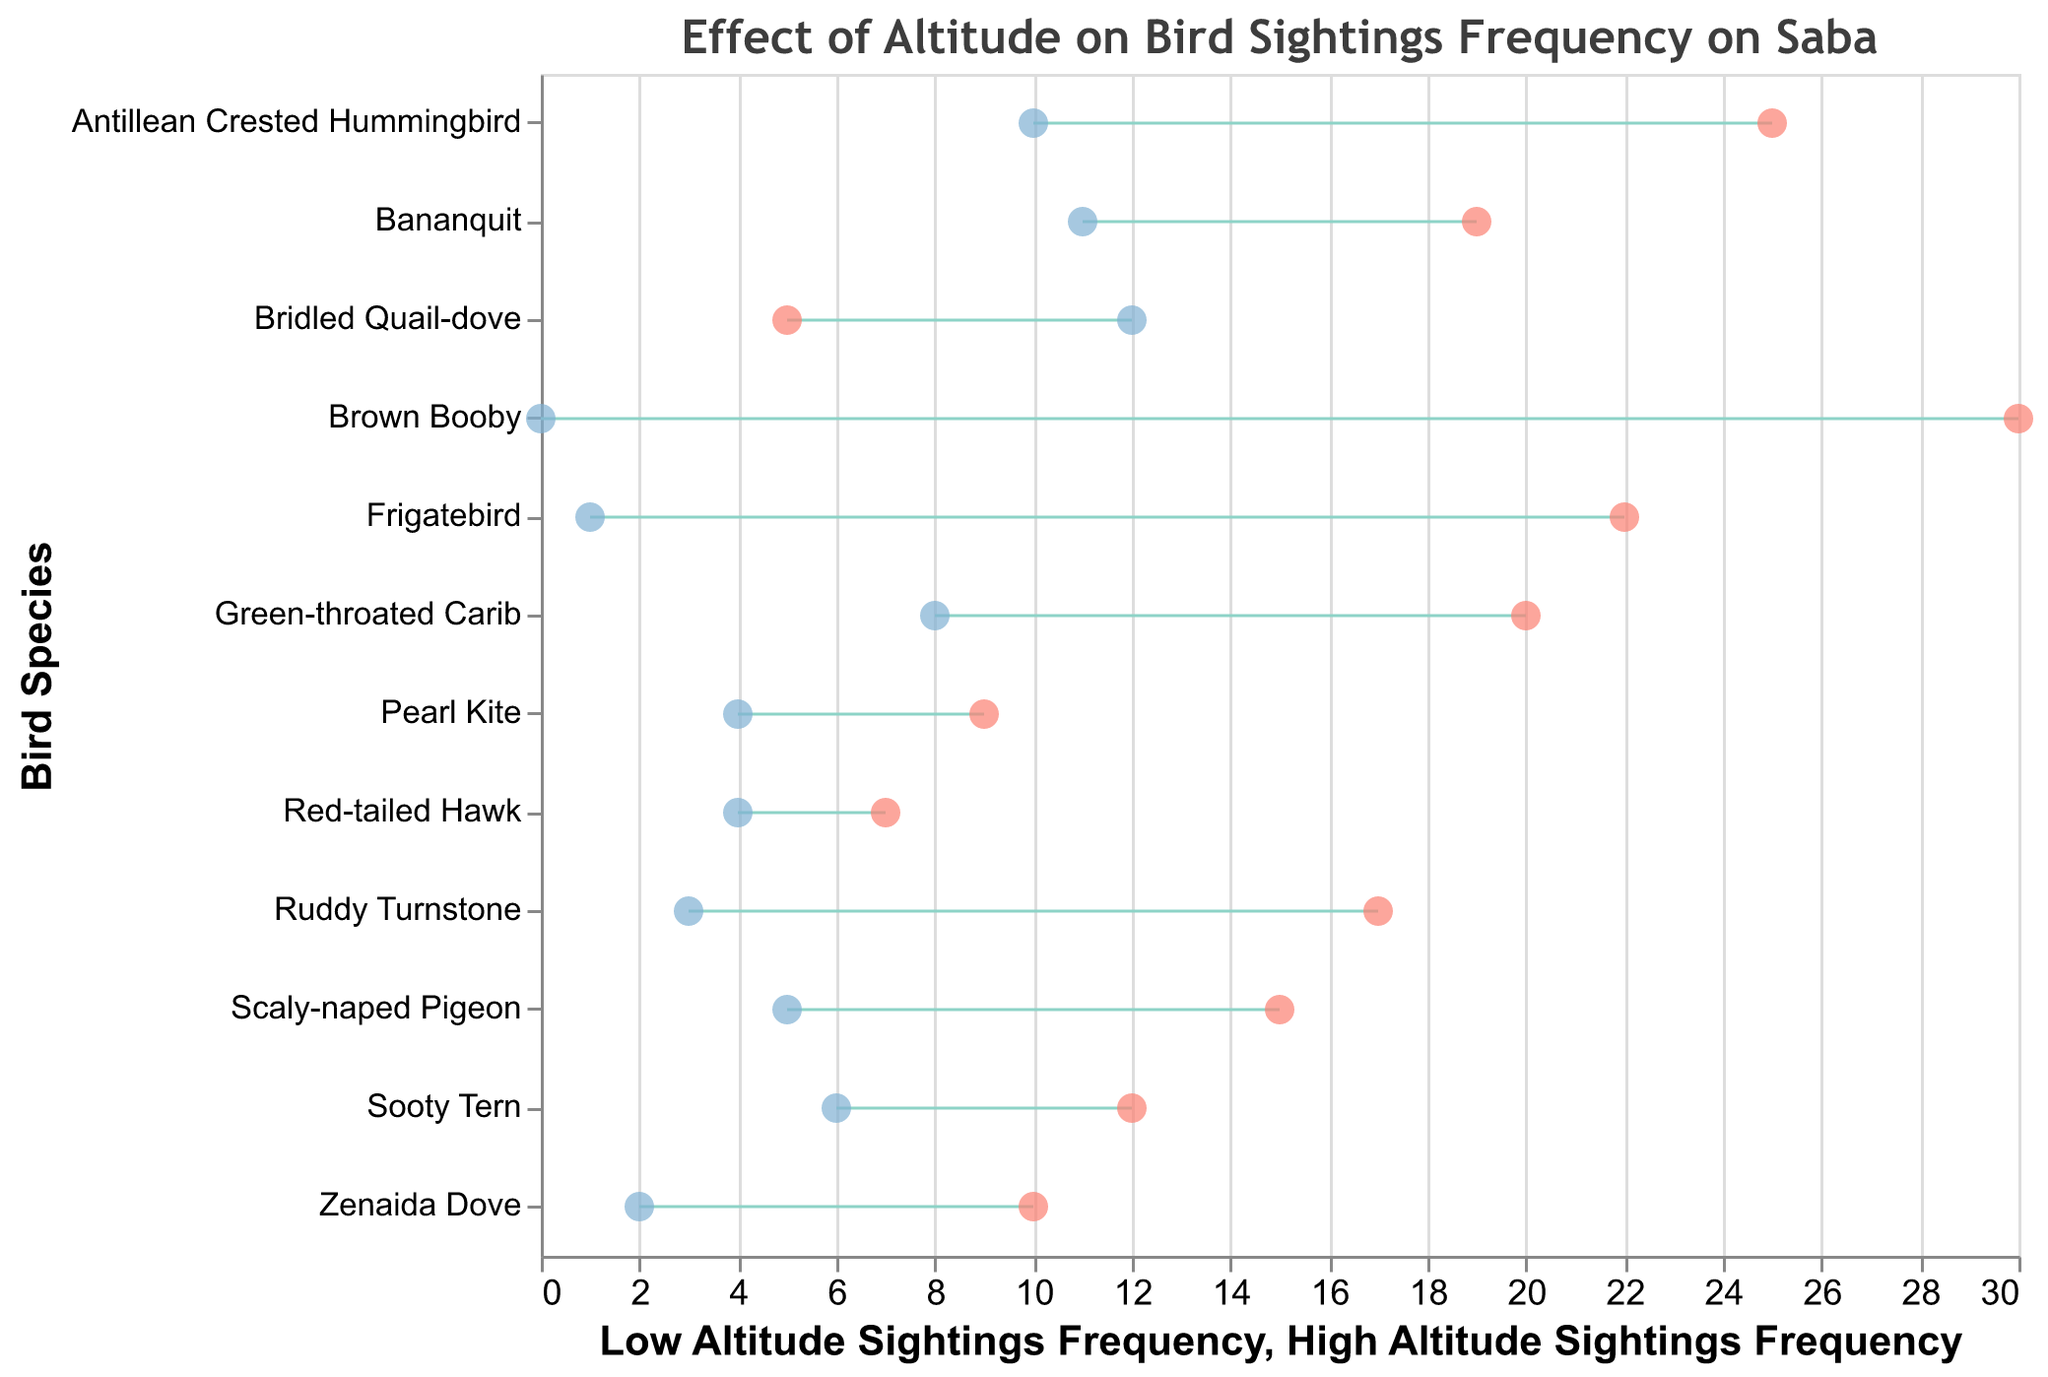Which bird species has the highest low altitude sightings frequency? From the Dumbbell Plot, the data points that show low altitude sightings are marked with one type of point. The bird species with the highest number of these points is the Antillean Crested Hummingbird.
Answer: Antillean Crested Hummingbird Which bird species is more commonly seen at higher altitudes, the Scaly-naped Pigeon or the Bridled Quail-dove? Comparing the high altitude sightings frequencies of the Scaly-naped Pigeon and the Bridled Quail-dove, we can see that the Bridled Quail-dove has 12 sightings while the Scaly-naped Pigeon only has 5.
Answer: Bridled Quail-dove What is the title of the Dumbbell Plot? The title of the figure is displayed at the top and provides the overall theme or subject of the visual. The title is "Effect of Altitude on Bird Sightings Frequency on Saba".
Answer: Effect of Altitude on Bird Sightings Frequency on Saba Which bird species at Well's Bay has the most significant difference in sightings frequency between low and high altitudes? To find the bird at Well's Bay with the most significant difference, we calculate the difference between low and high altitude sightings for each species there. The bird with the largest difference is the Brown Booby with a difference of 30 (30 - 0 = 30).
Answer: Brown Booby Is any bird species more frequently sighted at high altitudes than low altitudes? By comparing each bird species' low and high altitude sightings frequencies, we see that the only species with a higher number of sightings at high altitude is the Bridled Quail-dove.
Answer: Yes, Bridled Quail-dove How many bird species are depicted in the Dumbbell Plot? The y-axis of the Dumbbell Plot lists individual bird species vertically. Counting these, we find that there are 12 bird species displayed.
Answer: 12 Which location has the highest average low altitude sightings frequency? To find the location with the highest average low altitude sightings, we need to calculate and compare the averages for each location. Adding up the low altitude sightings and dividing by the number of species for each: 
Mount Scenery: (15 + 10 + 5) / 3 = 10
Mary's Point: (7 + 20 + 25) / 3 ≈ 17.33 
Well's Bay: (30 + 22 + 17) / 3 ≈ 23
Tent Reef: (12 + 19 + 9) / 3 ≈ 13.33
Well's Bay has the highest average.
Answer: Well's Bay What is the difference in sightings frequency at low altitude between the Green-throated Carib and the Sooty Tern? The low altitude sightings frequency for the Green-throated Carib is 20 and for the Sooty Tern is 12. Subtracting these, the difference is 20 - 12 = 8.
Answer: 8 Which bird species shows no high altitude sightings? By examining the high altitude sightings points, we see that the Brown Booby has a frequency of zero at high altitudes.
Answer: Brown Booby 